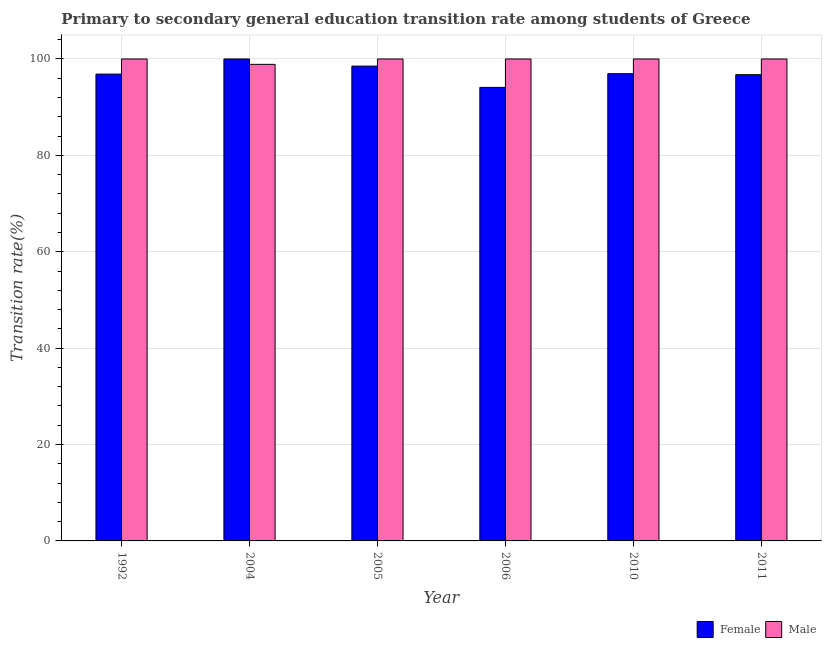Are the number of bars per tick equal to the number of legend labels?
Provide a succinct answer. Yes. Are the number of bars on each tick of the X-axis equal?
Make the answer very short. Yes. What is the label of the 2nd group of bars from the left?
Offer a terse response. 2004. In how many cases, is the number of bars for a given year not equal to the number of legend labels?
Your answer should be very brief. 0. What is the transition rate among male students in 2004?
Offer a terse response. 98.88. Across all years, what is the minimum transition rate among female students?
Offer a very short reply. 94.11. What is the total transition rate among male students in the graph?
Ensure brevity in your answer.  598.88. What is the difference between the transition rate among female students in 2004 and that in 2006?
Offer a very short reply. 5.89. What is the difference between the transition rate among female students in 2011 and the transition rate among male students in 2005?
Ensure brevity in your answer.  -1.78. What is the average transition rate among male students per year?
Offer a very short reply. 99.81. What is the ratio of the transition rate among female students in 2005 to that in 2011?
Give a very brief answer. 1.02. Is the difference between the transition rate among female students in 2005 and 2010 greater than the difference between the transition rate among male students in 2005 and 2010?
Offer a terse response. No. What is the difference between the highest and the second highest transition rate among female students?
Make the answer very short. 1.48. What is the difference between the highest and the lowest transition rate among male students?
Your response must be concise. 1.12. In how many years, is the transition rate among female students greater than the average transition rate among female students taken over all years?
Give a very brief answer. 2. Are all the bars in the graph horizontal?
Give a very brief answer. No. How many years are there in the graph?
Offer a terse response. 6. Where does the legend appear in the graph?
Provide a short and direct response. Bottom right. What is the title of the graph?
Give a very brief answer. Primary to secondary general education transition rate among students of Greece. Does "Imports" appear as one of the legend labels in the graph?
Provide a short and direct response. No. What is the label or title of the Y-axis?
Your answer should be compact. Transition rate(%). What is the Transition rate(%) of Female in 1992?
Your answer should be very brief. 96.86. What is the Transition rate(%) in Female in 2004?
Your answer should be compact. 100. What is the Transition rate(%) in Male in 2004?
Give a very brief answer. 98.88. What is the Transition rate(%) in Female in 2005?
Keep it short and to the point. 98.52. What is the Transition rate(%) of Male in 2005?
Give a very brief answer. 100. What is the Transition rate(%) in Female in 2006?
Offer a very short reply. 94.11. What is the Transition rate(%) in Female in 2010?
Your answer should be very brief. 96.95. What is the Transition rate(%) of Female in 2011?
Provide a succinct answer. 96.74. Across all years, what is the maximum Transition rate(%) of Female?
Make the answer very short. 100. Across all years, what is the maximum Transition rate(%) of Male?
Ensure brevity in your answer.  100. Across all years, what is the minimum Transition rate(%) of Female?
Offer a very short reply. 94.11. Across all years, what is the minimum Transition rate(%) of Male?
Your answer should be very brief. 98.88. What is the total Transition rate(%) in Female in the graph?
Provide a succinct answer. 583.17. What is the total Transition rate(%) of Male in the graph?
Ensure brevity in your answer.  598.88. What is the difference between the Transition rate(%) of Female in 1992 and that in 2004?
Make the answer very short. -3.14. What is the difference between the Transition rate(%) in Male in 1992 and that in 2004?
Your answer should be very brief. 1.12. What is the difference between the Transition rate(%) of Female in 1992 and that in 2005?
Offer a very short reply. -1.66. What is the difference between the Transition rate(%) in Female in 1992 and that in 2006?
Provide a succinct answer. 2.75. What is the difference between the Transition rate(%) in Male in 1992 and that in 2006?
Give a very brief answer. 0. What is the difference between the Transition rate(%) of Female in 1992 and that in 2010?
Your answer should be compact. -0.09. What is the difference between the Transition rate(%) in Male in 1992 and that in 2010?
Offer a terse response. 0. What is the difference between the Transition rate(%) in Female in 1992 and that in 2011?
Give a very brief answer. 0.12. What is the difference between the Transition rate(%) of Male in 1992 and that in 2011?
Give a very brief answer. 0. What is the difference between the Transition rate(%) in Female in 2004 and that in 2005?
Your answer should be very brief. 1.48. What is the difference between the Transition rate(%) of Male in 2004 and that in 2005?
Make the answer very short. -1.12. What is the difference between the Transition rate(%) of Female in 2004 and that in 2006?
Provide a short and direct response. 5.89. What is the difference between the Transition rate(%) of Male in 2004 and that in 2006?
Provide a succinct answer. -1.12. What is the difference between the Transition rate(%) in Female in 2004 and that in 2010?
Give a very brief answer. 3.05. What is the difference between the Transition rate(%) of Male in 2004 and that in 2010?
Offer a very short reply. -1.12. What is the difference between the Transition rate(%) in Female in 2004 and that in 2011?
Keep it short and to the point. 3.26. What is the difference between the Transition rate(%) in Male in 2004 and that in 2011?
Offer a very short reply. -1.12. What is the difference between the Transition rate(%) of Female in 2005 and that in 2006?
Offer a very short reply. 4.41. What is the difference between the Transition rate(%) in Male in 2005 and that in 2006?
Your answer should be compact. 0. What is the difference between the Transition rate(%) in Female in 2005 and that in 2010?
Provide a short and direct response. 1.57. What is the difference between the Transition rate(%) of Male in 2005 and that in 2010?
Provide a short and direct response. 0. What is the difference between the Transition rate(%) of Female in 2005 and that in 2011?
Make the answer very short. 1.78. What is the difference between the Transition rate(%) of Female in 2006 and that in 2010?
Offer a very short reply. -2.84. What is the difference between the Transition rate(%) in Female in 2006 and that in 2011?
Provide a succinct answer. -2.63. What is the difference between the Transition rate(%) of Male in 2006 and that in 2011?
Your answer should be compact. 0. What is the difference between the Transition rate(%) in Female in 2010 and that in 2011?
Your answer should be very brief. 0.21. What is the difference between the Transition rate(%) in Male in 2010 and that in 2011?
Your answer should be compact. 0. What is the difference between the Transition rate(%) in Female in 1992 and the Transition rate(%) in Male in 2004?
Provide a succinct answer. -2.02. What is the difference between the Transition rate(%) of Female in 1992 and the Transition rate(%) of Male in 2005?
Your response must be concise. -3.14. What is the difference between the Transition rate(%) of Female in 1992 and the Transition rate(%) of Male in 2006?
Ensure brevity in your answer.  -3.14. What is the difference between the Transition rate(%) in Female in 1992 and the Transition rate(%) in Male in 2010?
Make the answer very short. -3.14. What is the difference between the Transition rate(%) of Female in 1992 and the Transition rate(%) of Male in 2011?
Ensure brevity in your answer.  -3.14. What is the difference between the Transition rate(%) in Female in 2004 and the Transition rate(%) in Male in 2005?
Your answer should be very brief. 0. What is the difference between the Transition rate(%) in Female in 2004 and the Transition rate(%) in Male in 2006?
Your answer should be very brief. 0. What is the difference between the Transition rate(%) in Female in 2005 and the Transition rate(%) in Male in 2006?
Give a very brief answer. -1.48. What is the difference between the Transition rate(%) of Female in 2005 and the Transition rate(%) of Male in 2010?
Provide a short and direct response. -1.48. What is the difference between the Transition rate(%) of Female in 2005 and the Transition rate(%) of Male in 2011?
Provide a succinct answer. -1.48. What is the difference between the Transition rate(%) of Female in 2006 and the Transition rate(%) of Male in 2010?
Your answer should be very brief. -5.89. What is the difference between the Transition rate(%) in Female in 2006 and the Transition rate(%) in Male in 2011?
Ensure brevity in your answer.  -5.89. What is the difference between the Transition rate(%) in Female in 2010 and the Transition rate(%) in Male in 2011?
Provide a short and direct response. -3.05. What is the average Transition rate(%) of Female per year?
Keep it short and to the point. 97.2. What is the average Transition rate(%) of Male per year?
Ensure brevity in your answer.  99.81. In the year 1992, what is the difference between the Transition rate(%) in Female and Transition rate(%) in Male?
Give a very brief answer. -3.14. In the year 2004, what is the difference between the Transition rate(%) in Female and Transition rate(%) in Male?
Offer a terse response. 1.12. In the year 2005, what is the difference between the Transition rate(%) of Female and Transition rate(%) of Male?
Give a very brief answer. -1.48. In the year 2006, what is the difference between the Transition rate(%) of Female and Transition rate(%) of Male?
Your answer should be very brief. -5.89. In the year 2010, what is the difference between the Transition rate(%) in Female and Transition rate(%) in Male?
Offer a terse response. -3.05. In the year 2011, what is the difference between the Transition rate(%) in Female and Transition rate(%) in Male?
Your answer should be compact. -3.26. What is the ratio of the Transition rate(%) of Female in 1992 to that in 2004?
Your response must be concise. 0.97. What is the ratio of the Transition rate(%) of Male in 1992 to that in 2004?
Make the answer very short. 1.01. What is the ratio of the Transition rate(%) of Female in 1992 to that in 2005?
Your answer should be compact. 0.98. What is the ratio of the Transition rate(%) in Female in 1992 to that in 2006?
Your answer should be very brief. 1.03. What is the ratio of the Transition rate(%) in Female in 1992 to that in 2010?
Offer a terse response. 1. What is the ratio of the Transition rate(%) in Female in 1992 to that in 2011?
Offer a very short reply. 1. What is the ratio of the Transition rate(%) of Male in 1992 to that in 2011?
Make the answer very short. 1. What is the ratio of the Transition rate(%) of Female in 2004 to that in 2006?
Ensure brevity in your answer.  1.06. What is the ratio of the Transition rate(%) in Male in 2004 to that in 2006?
Provide a short and direct response. 0.99. What is the ratio of the Transition rate(%) of Female in 2004 to that in 2010?
Make the answer very short. 1.03. What is the ratio of the Transition rate(%) in Female in 2004 to that in 2011?
Provide a short and direct response. 1.03. What is the ratio of the Transition rate(%) in Male in 2004 to that in 2011?
Your answer should be very brief. 0.99. What is the ratio of the Transition rate(%) of Female in 2005 to that in 2006?
Your response must be concise. 1.05. What is the ratio of the Transition rate(%) of Male in 2005 to that in 2006?
Offer a terse response. 1. What is the ratio of the Transition rate(%) of Female in 2005 to that in 2010?
Make the answer very short. 1.02. What is the ratio of the Transition rate(%) in Male in 2005 to that in 2010?
Ensure brevity in your answer.  1. What is the ratio of the Transition rate(%) of Female in 2005 to that in 2011?
Provide a short and direct response. 1.02. What is the ratio of the Transition rate(%) of Female in 2006 to that in 2010?
Your response must be concise. 0.97. What is the ratio of the Transition rate(%) of Female in 2006 to that in 2011?
Provide a short and direct response. 0.97. What is the ratio of the Transition rate(%) of Male in 2006 to that in 2011?
Offer a terse response. 1. What is the ratio of the Transition rate(%) in Female in 2010 to that in 2011?
Keep it short and to the point. 1. What is the difference between the highest and the second highest Transition rate(%) in Female?
Make the answer very short. 1.48. What is the difference between the highest and the lowest Transition rate(%) in Female?
Your response must be concise. 5.89. What is the difference between the highest and the lowest Transition rate(%) in Male?
Give a very brief answer. 1.12. 